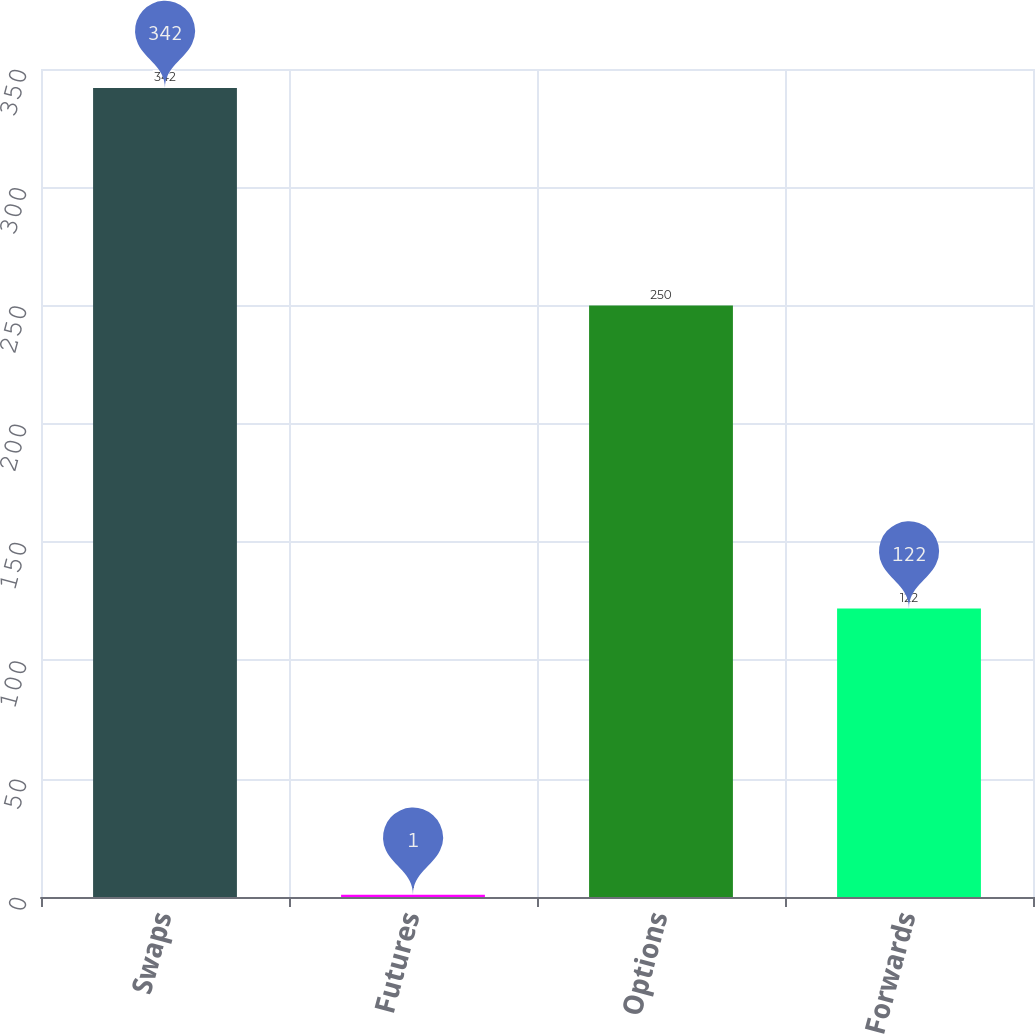Convert chart. <chart><loc_0><loc_0><loc_500><loc_500><bar_chart><fcel>Swaps<fcel>Futures<fcel>Options<fcel>Forwards<nl><fcel>342<fcel>1<fcel>250<fcel>122<nl></chart> 